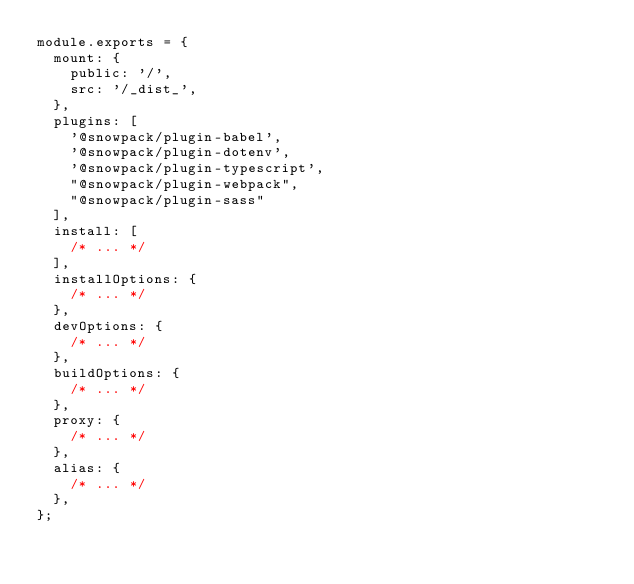<code> <loc_0><loc_0><loc_500><loc_500><_JavaScript_>module.exports = {
  mount: {
    public: '/',
    src: '/_dist_',
  },
  plugins: [
    '@snowpack/plugin-babel',
    '@snowpack/plugin-dotenv',
    '@snowpack/plugin-typescript',
    "@snowpack/plugin-webpack",
    "@snowpack/plugin-sass"
  ],
  install: [
    /* ... */
  ],
  installOptions: {
    /* ... */
  },
  devOptions: {
    /* ... */
  },
  buildOptions: {
    /* ... */
  },
  proxy: {
    /* ... */
  },
  alias: {
    /* ... */
  },
};
</code> 